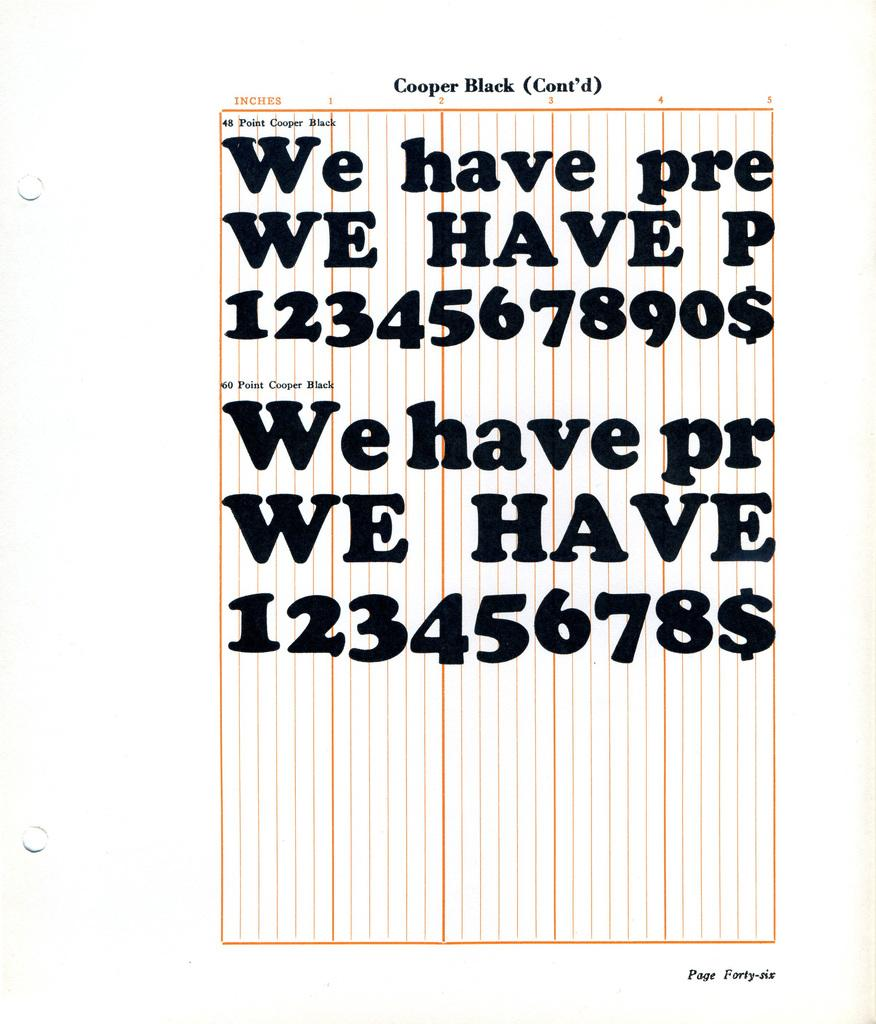<image>
Summarize the visual content of the image. Page from a book that is titled "Cooper Black". 